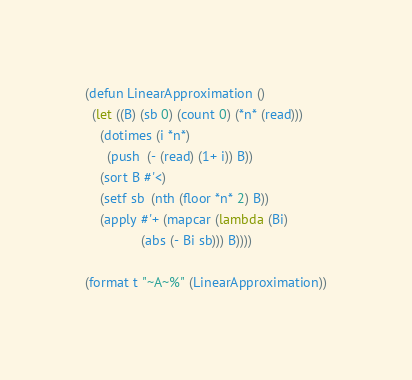<code> <loc_0><loc_0><loc_500><loc_500><_Lisp_>(defun LinearApproximation ()
  (let ((B) (sb 0) (count 0) (*n* (read)))
    (dotimes (i *n*)
      (push  (- (read) (1+ i)) B))
    (sort B #'<)
    (setf sb  (nth (floor *n* 2) B))
    (apply #'+ (mapcar (lambda (Bi)
               (abs (- Bi sb))) B))))
 
(format t "~A~%" (LinearApproximation))</code> 